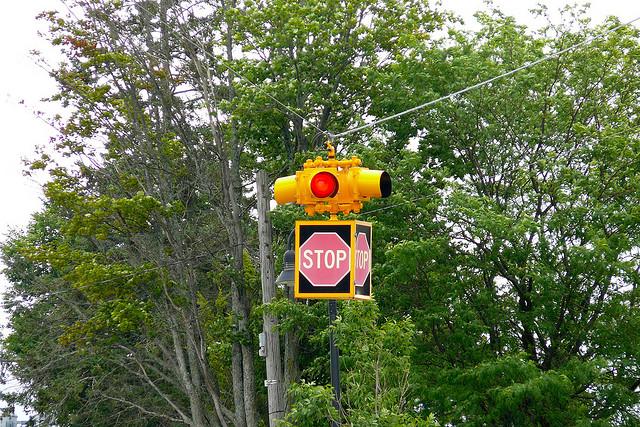What color is the street light?
Keep it brief. Red. What is in the background of the image?
Quick response, please. Trees. Is there a stop sign with red light?
Keep it brief. Yes. Is redundancy shown here?
Short answer required. Yes. What does the sign below the lights indicate?
Quick response, please. Stop. 